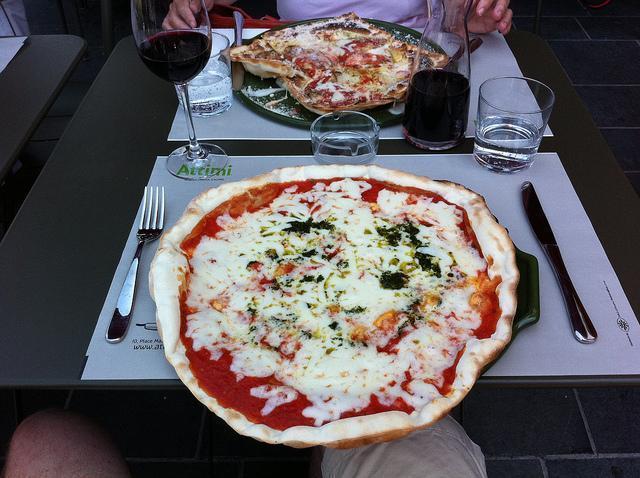How many glasses are on the table?
Give a very brief answer. 4. How many pizzas are on the table?
Give a very brief answer. 2. How many dining tables are there?
Give a very brief answer. 2. How many wine glasses are in the picture?
Give a very brief answer. 1. How many cups are there?
Give a very brief answer. 4. How many pizzas are there?
Give a very brief answer. 2. How many people are there?
Give a very brief answer. 2. 